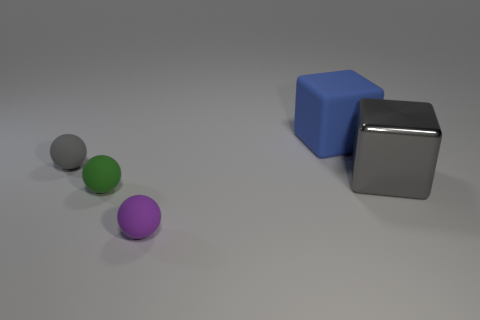Is there any other thing that has the same material as the big gray cube?
Offer a terse response. No. What is the sphere that is behind the object right of the blue matte cube made of?
Make the answer very short. Rubber. Is the number of small green spheres that are to the left of the tiny green thing less than the number of purple metallic things?
Your answer should be compact. No. What is the shape of the small gray object that is made of the same material as the large blue object?
Offer a very short reply. Sphere. How many other things are the same shape as the small green object?
Your answer should be compact. 2. What number of blue things are rubber blocks or small rubber objects?
Offer a terse response. 1. Is the green thing the same shape as the purple matte thing?
Keep it short and to the point. Yes. There is a rubber thing right of the purple matte object; is there a large thing right of it?
Ensure brevity in your answer.  Yes. Is the number of blue things to the left of the tiny gray rubber thing the same as the number of small red cylinders?
Make the answer very short. Yes. What number of other things are there of the same size as the purple rubber object?
Ensure brevity in your answer.  2. 